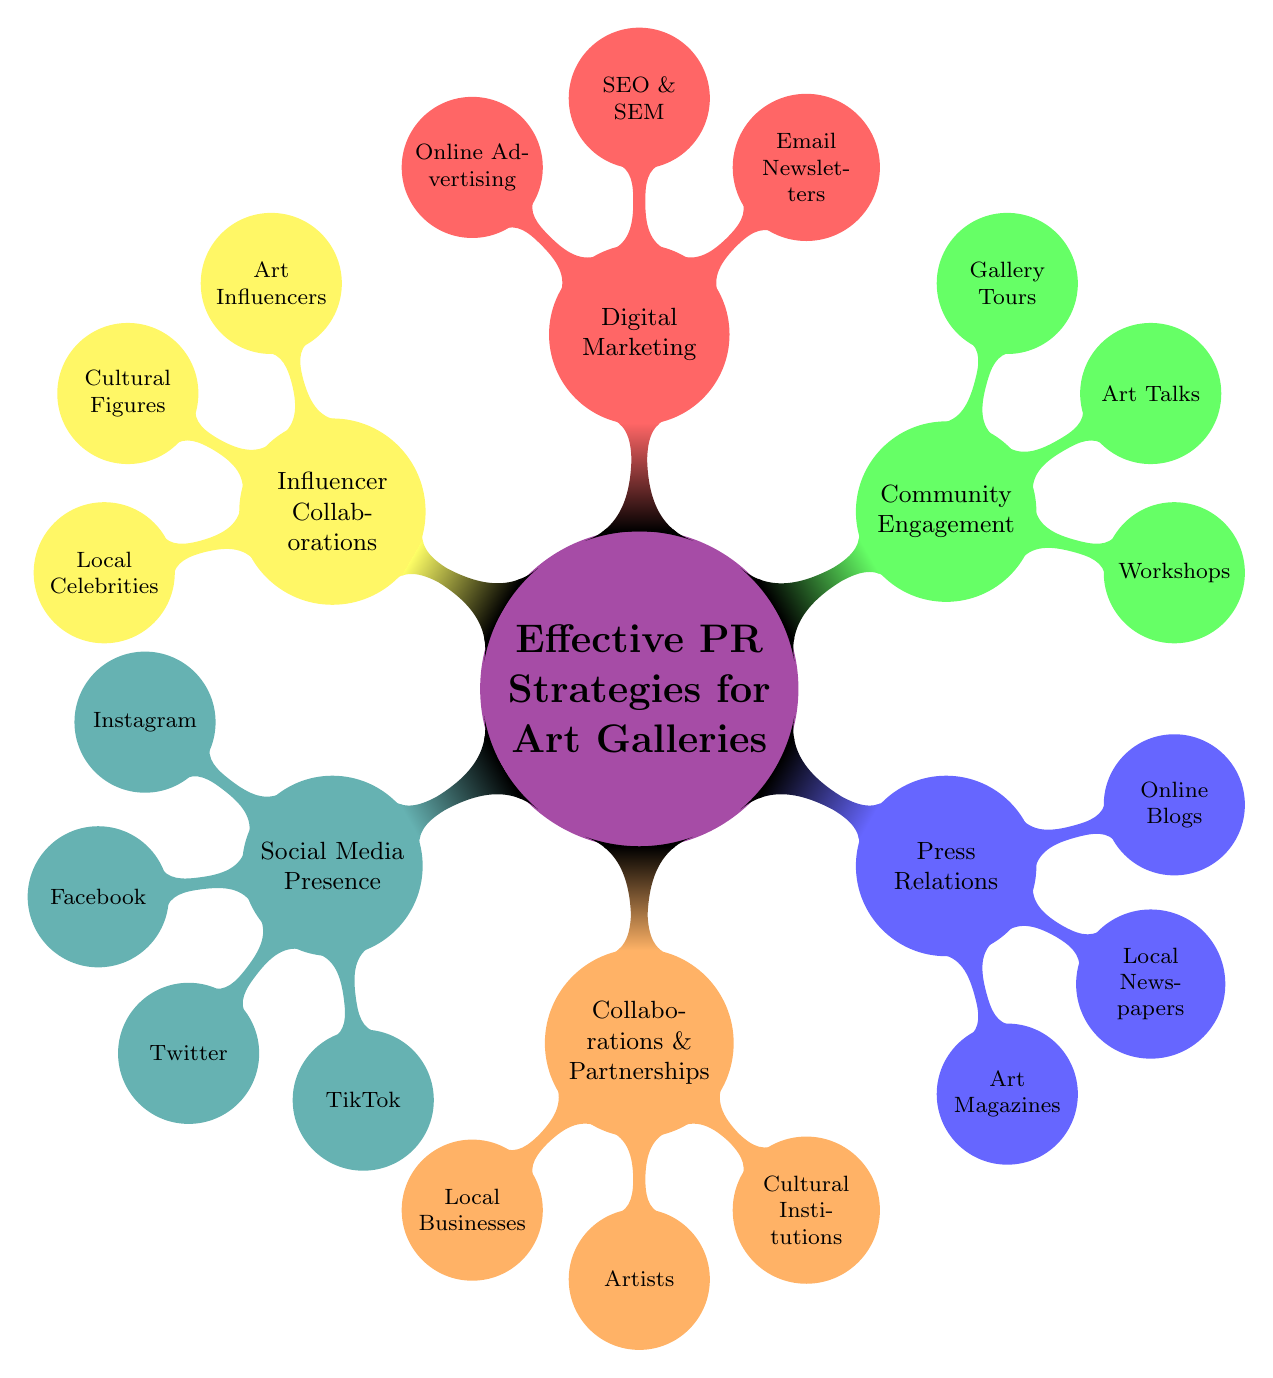What's the central theme of the diagram? The diagram is centered on the theme “Effective PR Strategies for Art Galleries,” which is indicated as the main node.
Answer: Effective PR Strategies for Art Galleries How many primary strategies are listed in the diagram? The diagram contains six primary strategies that branch out from the central theme. By counting them, we find the numbers: Social Media Presence, Collaborations & Partnerships, Press Relations, Community Engagement, Digital Marketing, and Influencer Collaborations.
Answer: Six What are the platforms mentioned under Social Media Presence? The platforms mentioned are listed as child nodes under the Social Media Presence node. They include Instagram, Facebook, Twitter, and TikTok.
Answer: Instagram, Facebook, Twitter, TikTok What types of entities are included in Collaborations & Partnerships? The diagram indicates three types of entities involved in Collaborations & Partnerships, which are Local Businesses, Artists, and Cultural Institutions.
Answer: Local Businesses, Artists, Cultural Institutions Which primary strategy is related to Media Outlets? The primary strategy that pertains to Media Outlets, indicating its focus on press release activities, is identified as Press Relations in the diagram.
Answer: Press Relations What is the connection between Digital Marketing and tools used? The connection is that Digital Marketing includes a subcategory where various tools are listed, namely Mailchimp, Google Analytics, and Hootsuite, emphasizing its importance for effective outreach.
Answer: Mailchimp, Google Analytics, Hootsuite How are Influencer Collaborations described in terms of types? Influencer Collaborations include broad categories, specifically Art Influencers, Cultural Figures, and Local Celebrities, emphasizing diverse engagement strategies that art galleries can adopt.
Answer: Art Influencers, Cultural Figures, Local Celebrities What activity is associated with Community Engagement? Workshops, Art Talks, and Gallery Tours are activities associated with Community Engagement as outlined in the diagram, highlighting ways galleries can connect with their audience.
Answer: Workshops, Art Talks, Gallery Tours Which type of content is recommended for Social Media Presence? The recommended types of content that are suggested for engagement on social media include Exhibit Previews, Artist Interviews, and Behind-the-Scenes, focusing on enriching audience experience.
Answer: Exhibit Previews, Artist Interviews, Behind-the-Scenes 